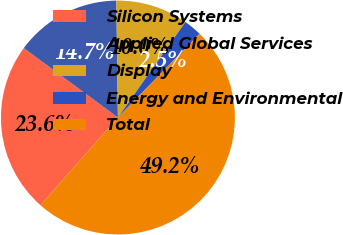Convert chart to OTSL. <chart><loc_0><loc_0><loc_500><loc_500><pie_chart><fcel>Silicon Systems<fcel>Applied Global Services<fcel>Display<fcel>Energy and Environmental<fcel>Total<nl><fcel>23.61%<fcel>14.67%<fcel>10.0%<fcel>2.51%<fcel>49.2%<nl></chart> 